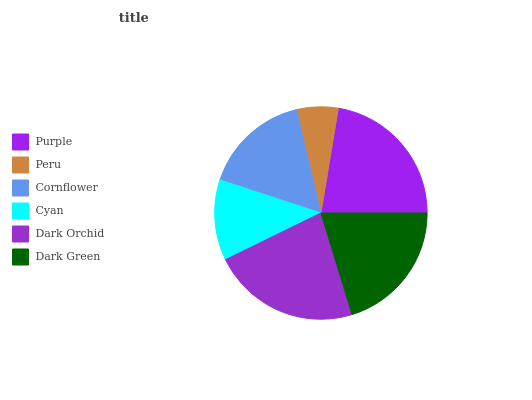Is Peru the minimum?
Answer yes or no. Yes. Is Dark Orchid the maximum?
Answer yes or no. Yes. Is Cornflower the minimum?
Answer yes or no. No. Is Cornflower the maximum?
Answer yes or no. No. Is Cornflower greater than Peru?
Answer yes or no. Yes. Is Peru less than Cornflower?
Answer yes or no. Yes. Is Peru greater than Cornflower?
Answer yes or no. No. Is Cornflower less than Peru?
Answer yes or no. No. Is Dark Green the high median?
Answer yes or no. Yes. Is Cornflower the low median?
Answer yes or no. Yes. Is Dark Orchid the high median?
Answer yes or no. No. Is Peru the low median?
Answer yes or no. No. 